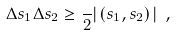<formula> <loc_0><loc_0><loc_500><loc_500>\Delta s _ { 1 } \Delta s _ { 2 } \geq \frac { } { 2 } | \left ( s _ { 1 } , s _ { 2 } \right ) | \ ,</formula> 